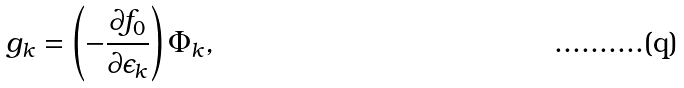<formula> <loc_0><loc_0><loc_500><loc_500>g _ { k } = \left ( - \frac { \partial f _ { 0 } } { \partial \epsilon _ { k } } \right ) \Phi _ { k } ,</formula> 